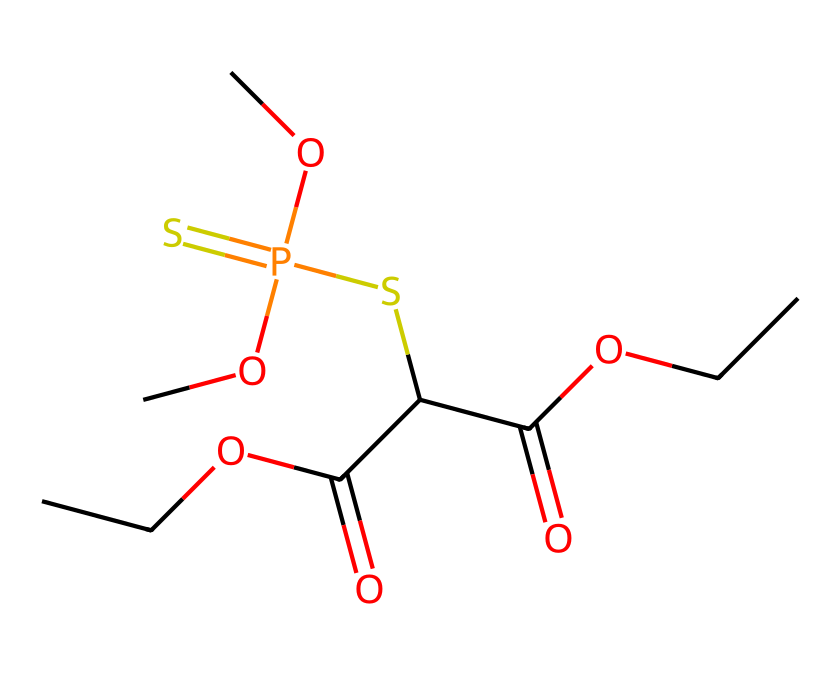What is the total number of carbon atoms in malathion? By examining the SMILES representation, we can count the number of 'C' characters. There are 9 carbon atoms present in the structure.
Answer: 9 How many oxygen atoms are present in this molecule? In the provided SMILES, we identify the number of 'O' characters to determine the number of oxygen atoms. There are 6 oxygen atoms in total.
Answer: 6 What type of chemical is malathion classified as? Malathion is classified as an organophosphate pesticide. This classification arises from its phosphorus atom and its use as a pesticide.
Answer: organophosphate Does this pesticide contain any sulfur atoms? Examining the SMILES, we can find the 'S' character which indicates the presence of sulfur. There is 1 sulfur atom in this structure.
Answer: 1 What functional groups are present in malathion? By analyzing the SMILES representation, we can identify ester and thioester functional groups due to the presence of both carbonyls and the sulfur atom connected to an alkyl chain.
Answer: ester and thioester How many phosphorus atoms are in the molecular structure? In the SMILES, we look for the 'P' character, indicating phosphorus atoms in the molecule. There is 1 phosphorus atom identified in the chemical structure.
Answer: 1 What is the role of malathion in relation to mosquitoes? Malathion is used primarily as an insecticide to control mosquito populations. This is inferred from its classification as a pesticide and its application context in mosquito control.
Answer: insecticide 